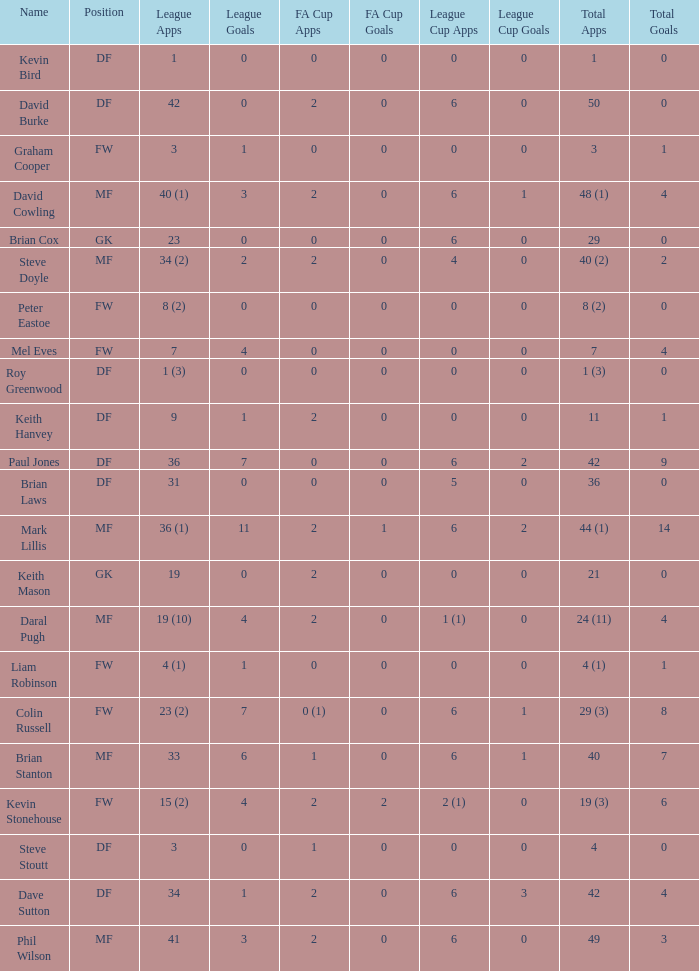What is the most total goals for a player having 0 FA Cup goals and 41 League appearances? 3.0. 